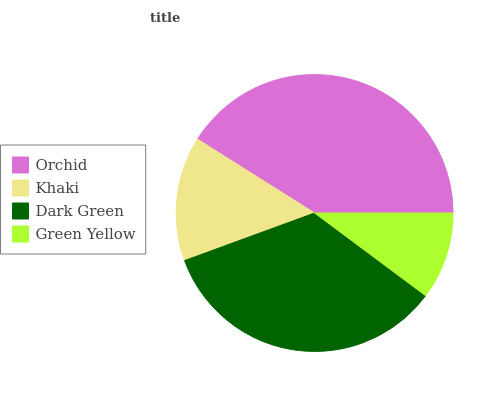Is Green Yellow the minimum?
Answer yes or no. Yes. Is Orchid the maximum?
Answer yes or no. Yes. Is Khaki the minimum?
Answer yes or no. No. Is Khaki the maximum?
Answer yes or no. No. Is Orchid greater than Khaki?
Answer yes or no. Yes. Is Khaki less than Orchid?
Answer yes or no. Yes. Is Khaki greater than Orchid?
Answer yes or no. No. Is Orchid less than Khaki?
Answer yes or no. No. Is Dark Green the high median?
Answer yes or no. Yes. Is Khaki the low median?
Answer yes or no. Yes. Is Green Yellow the high median?
Answer yes or no. No. Is Orchid the low median?
Answer yes or no. No. 